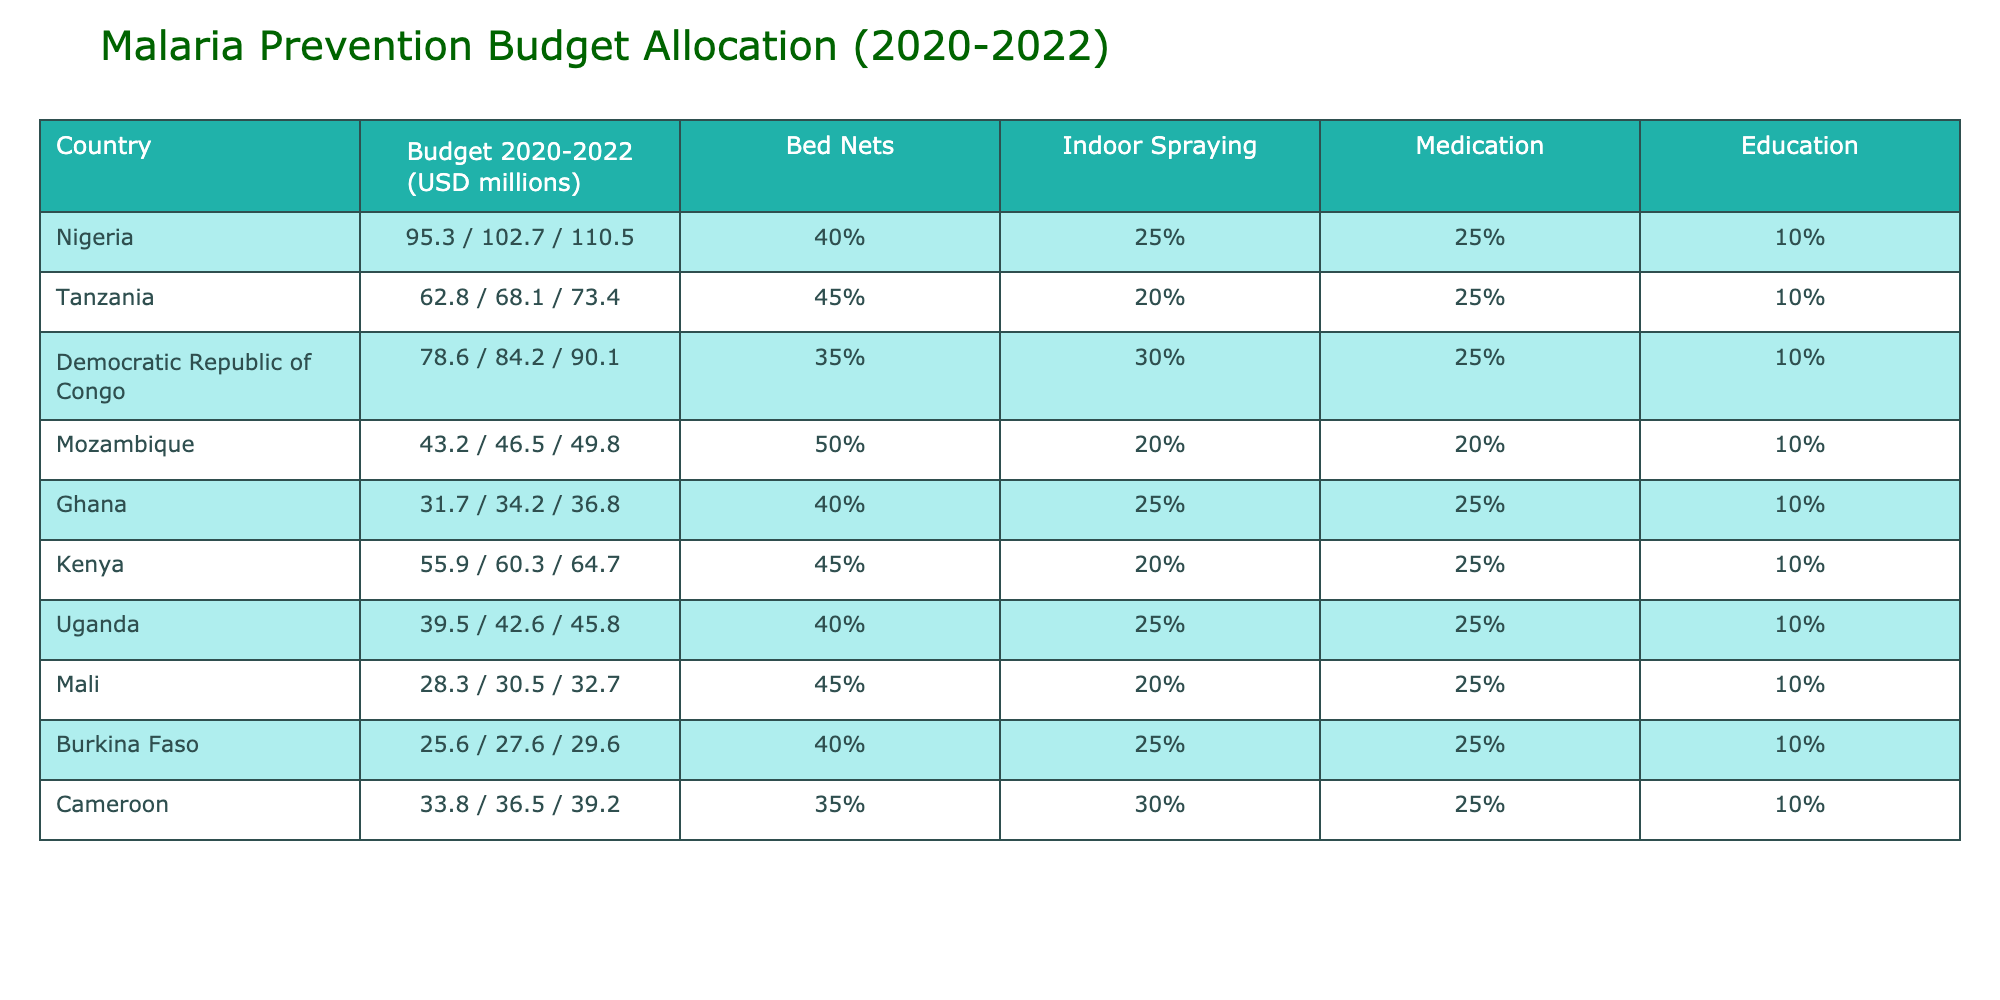What was the budget of Nigeria for malaria prevention in 2022? Looking at the table, Nigeria's budget for malaria prevention in 2022 is listed as 110.5 million USD.
Answer: 110.5 million USD Which country allocated the highest percentage for bed nets in their budget? Referring to the percentage for bed nets, Mozambique allocated the highest percentage at 50%.
Answer: Mozambique What is the total budget allocated by Tanzania for the years 2020 to 2022? The budgets for Tanzania in each year are 62.8 million, 68.1 million, and 73.4 million. Adding these gives 62.8 + 68.1 + 73.4 = 204.3 million USD.
Answer: 204.3 million USD Did Ghana allocate more than 35% of its budget for medication in 2022? The table shows that Ghana allocated 25% for medication, which is not more than 35%.
Answer: No What is the average budget for malaria prevention in the Democratic Republic of Congo over the three years? The budgets for the Democratic Republic of Congo are 78.6 million, 84.2 million, and 90.1 million. The total is 78.6 + 84.2 + 90.1 = 252.9 million, and dividing by 3 gives an average of 252.9 / 3 = 84.3 million USD.
Answer: 84.3 million USD Which country's budget for 2021 is greater than 100 million USD? The table shows that only Nigeria has a budget of 102.7 million for 2021, which is greater than 100 million USD.
Answer: Yes What was the total percentage of budget allocation for bed nets in Mali and Burkina Faso? Mali allocated 45% and Burkina Faso allocated 40% for bed nets. Adding these percentages gives 45 + 40 = 85%.
Answer: 85% Which country has the lowest budget allocation across the three years? By examining the budgets, Mali has the lowest budget total of 28.3 million, 30.5 million, and 32.7 million, equating to a total of 91.5 million.
Answer: Mali Was there an increase in Uganda's budget from 2020 to 2022? Uganda's budgets are 39.5 million in 2020 and 45.8 million in 2022. There is an increase: 45.8 - 39.5 = 6.3 million.
Answer: Yes Which two countries allocated equal budget amounts for education across the years? The table shows that all countries allocated 10% for education, indicating that no specific amounts were equal but percentages were consistent across countries.
Answer: All allocated 10% 